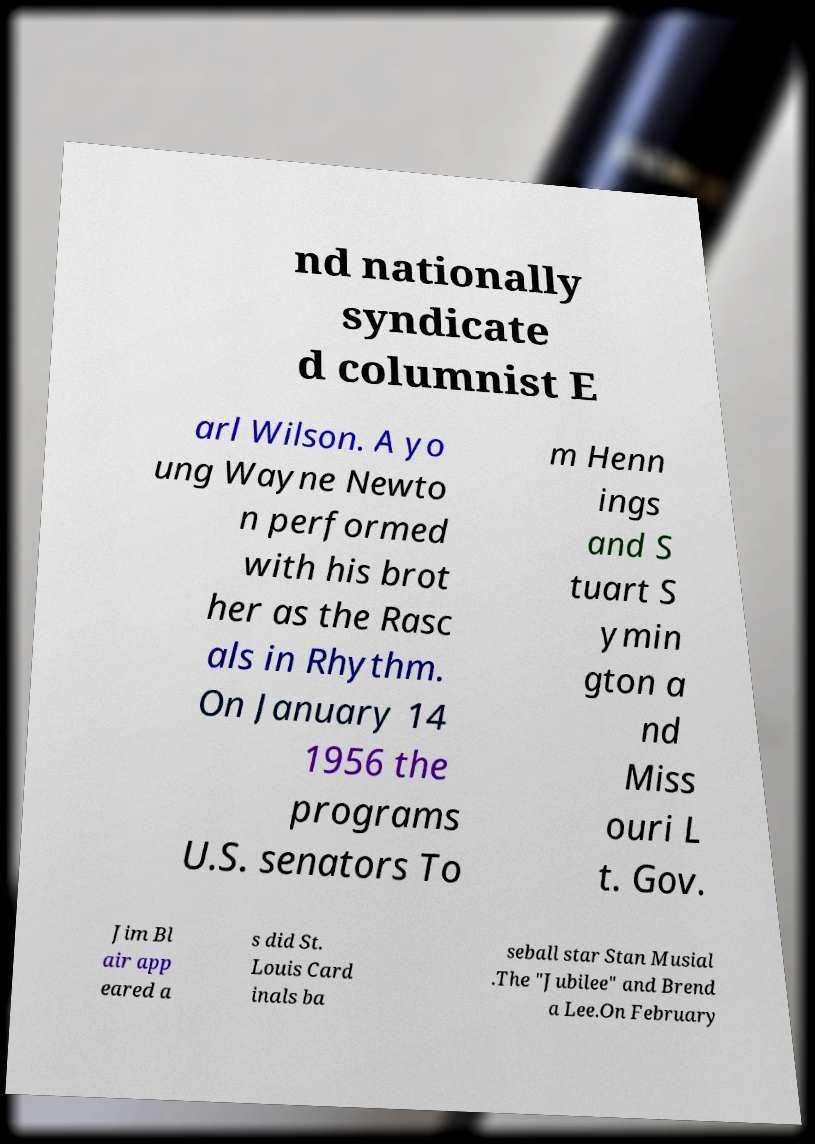Please read and relay the text visible in this image. What does it say? nd nationally syndicate d columnist E arl Wilson. A yo ung Wayne Newto n performed with his brot her as the Rasc als in Rhythm. On January 14 1956 the programs U.S. senators To m Henn ings and S tuart S ymin gton a nd Miss ouri L t. Gov. Jim Bl air app eared a s did St. Louis Card inals ba seball star Stan Musial .The "Jubilee" and Brend a Lee.On February 